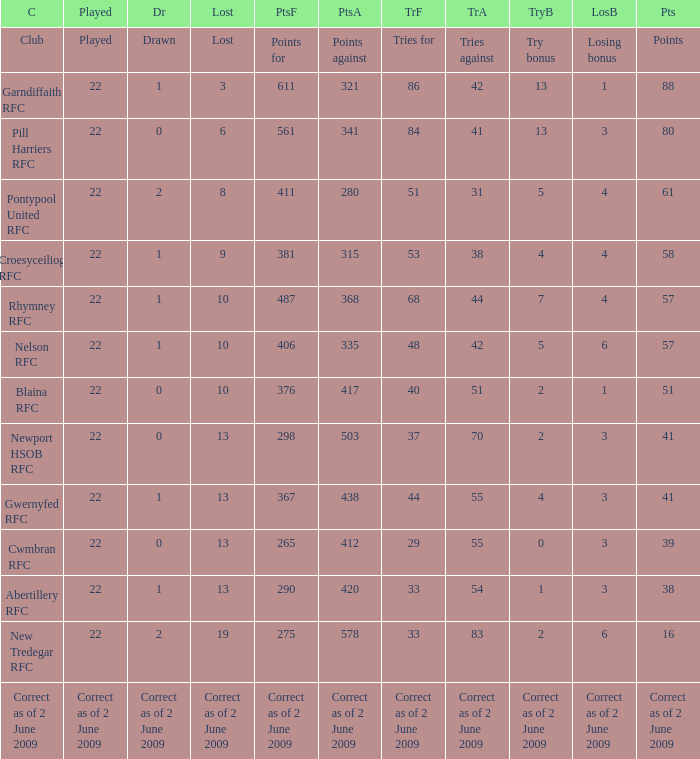How many points against did the club with a losing bonus of 3 and 84 tries have? 341.0. 